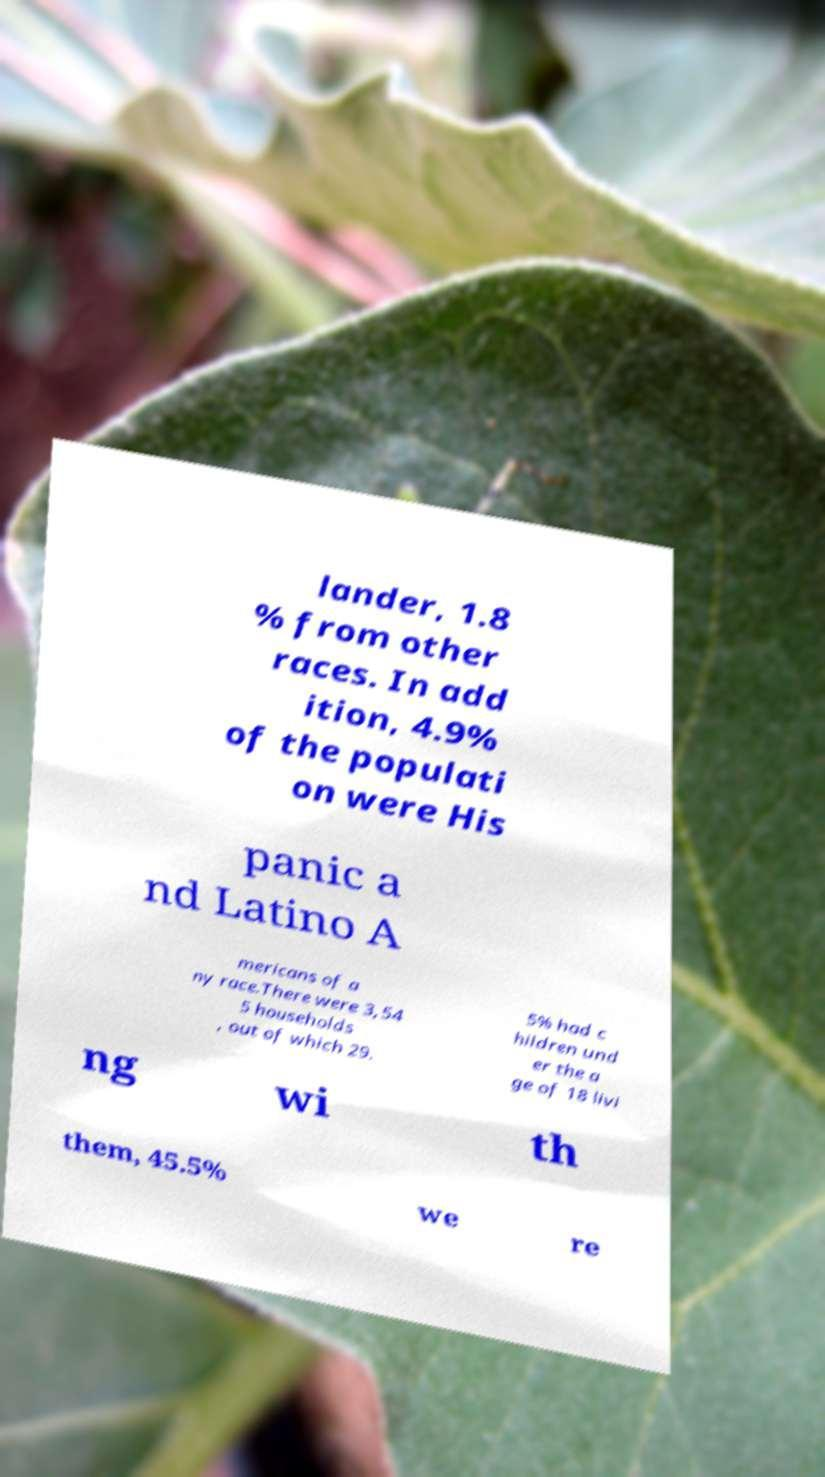Please read and relay the text visible in this image. What does it say? lander, 1.8 % from other races. In add ition, 4.9% of the populati on were His panic a nd Latino A mericans of a ny race.There were 3,54 5 households , out of which 29. 5% had c hildren und er the a ge of 18 livi ng wi th them, 45.5% we re 